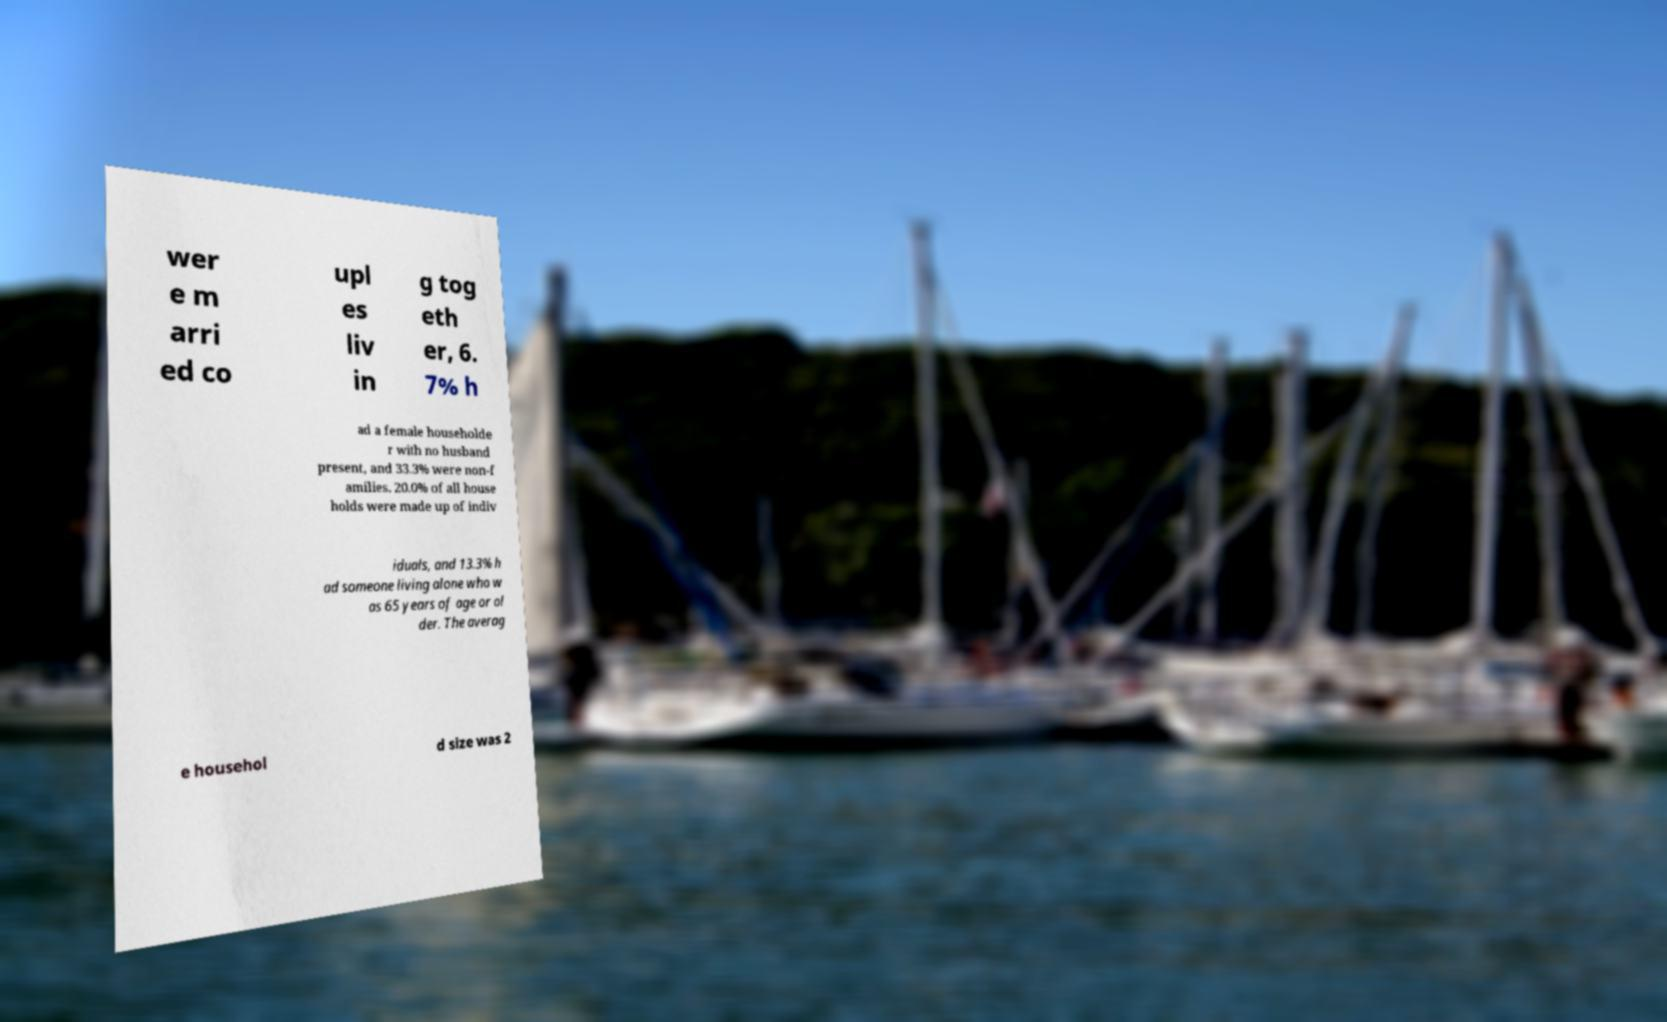For documentation purposes, I need the text within this image transcribed. Could you provide that? wer e m arri ed co upl es liv in g tog eth er, 6. 7% h ad a female householde r with no husband present, and 33.3% were non-f amilies. 20.0% of all house holds were made up of indiv iduals, and 13.3% h ad someone living alone who w as 65 years of age or ol der. The averag e househol d size was 2 